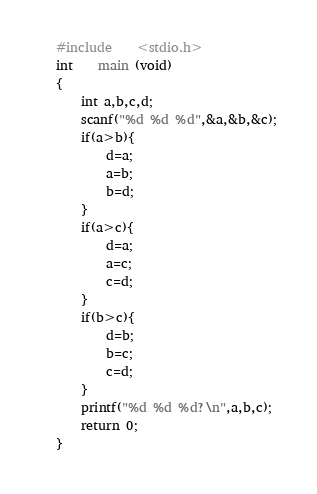<code> <loc_0><loc_0><loc_500><loc_500><_C_>#include    <stdio.h>
int    main (void)
{ 
    int a,b,c,d;
    scanf("%d %d %d",&a,&b,&c);
    if(a>b){
        d=a;
        a=b;
        b=d;
    }
    if(a>c){
        d=a;
        a=c;
        c=d;
    }
    if(b>c){
        d=b;
        b=c;
        c=d;
    }
    printf("%d %d %d?\n",a,b,c);
    return 0;
}</code> 